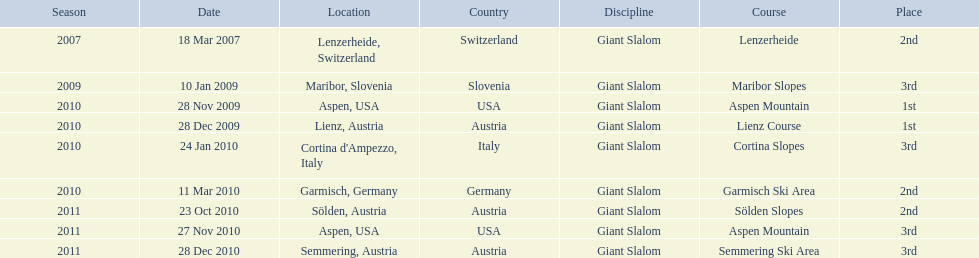The final race finishing place was not 1st but what other place? 3rd. 